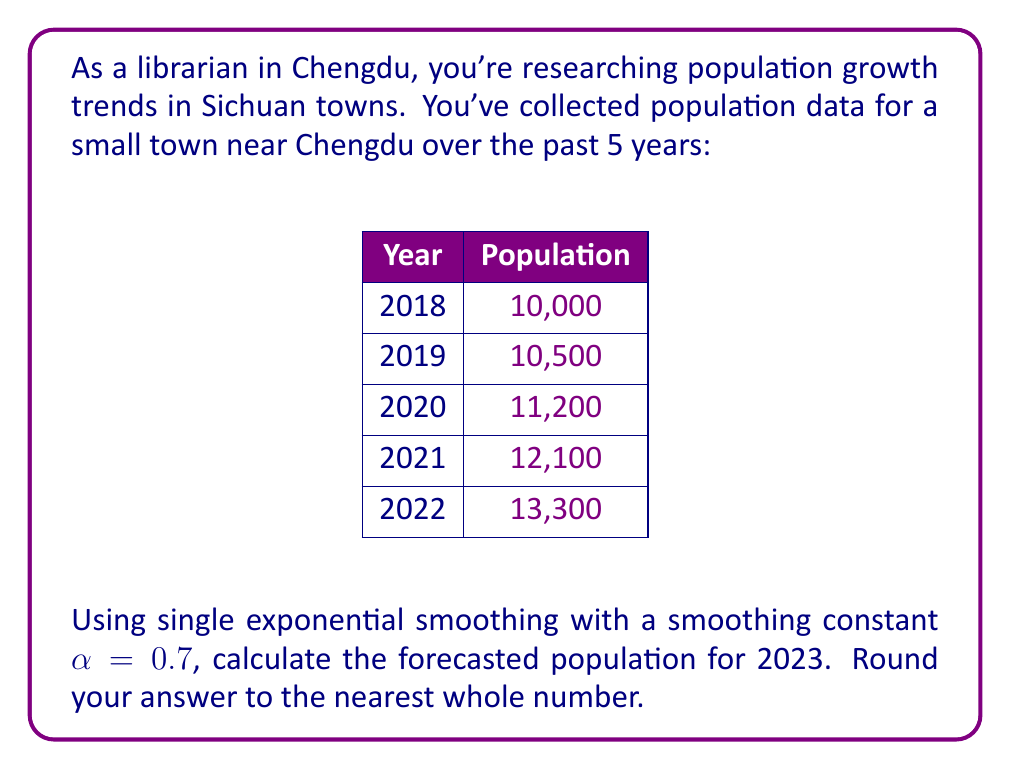Can you answer this question? To solve this problem using single exponential smoothing, we'll follow these steps:

1) The formula for single exponential smoothing is:

   $$F_{t+1} = \alpha Y_t + (1-\alpha)F_t$$

   Where:
   $F_{t+1}$ is the forecast for the next period
   $\alpha$ is the smoothing constant (0.7 in this case)
   $Y_t$ is the actual value at time t
   $F_t$ is the forecast for the current period

2) We start with the initial forecast $F_1$ equal to the first actual value:

   $F_1 = 10,000$

3) Now we calculate each subsequent forecast:

   For 2019: $F_2 = 0.7(10,000) + 0.3(10,000) = 10,000$
   For 2020: $F_3 = 0.7(10,500) + 0.3(10,000) = 10,350$
   For 2021: $F_4 = 0.7(11,200) + 0.3(10,350) = 10,945$
   For 2022: $F_5 = 0.7(12,100) + 0.3(10,945) = 11,753.5$

4) Finally, for the 2023 forecast:

   $F_6 = 0.7(13,300) + 0.3(11,753.5) = 12,836.05$

5) Rounding to the nearest whole number:

   $F_6 \approx 12,836$
Answer: 12,836 